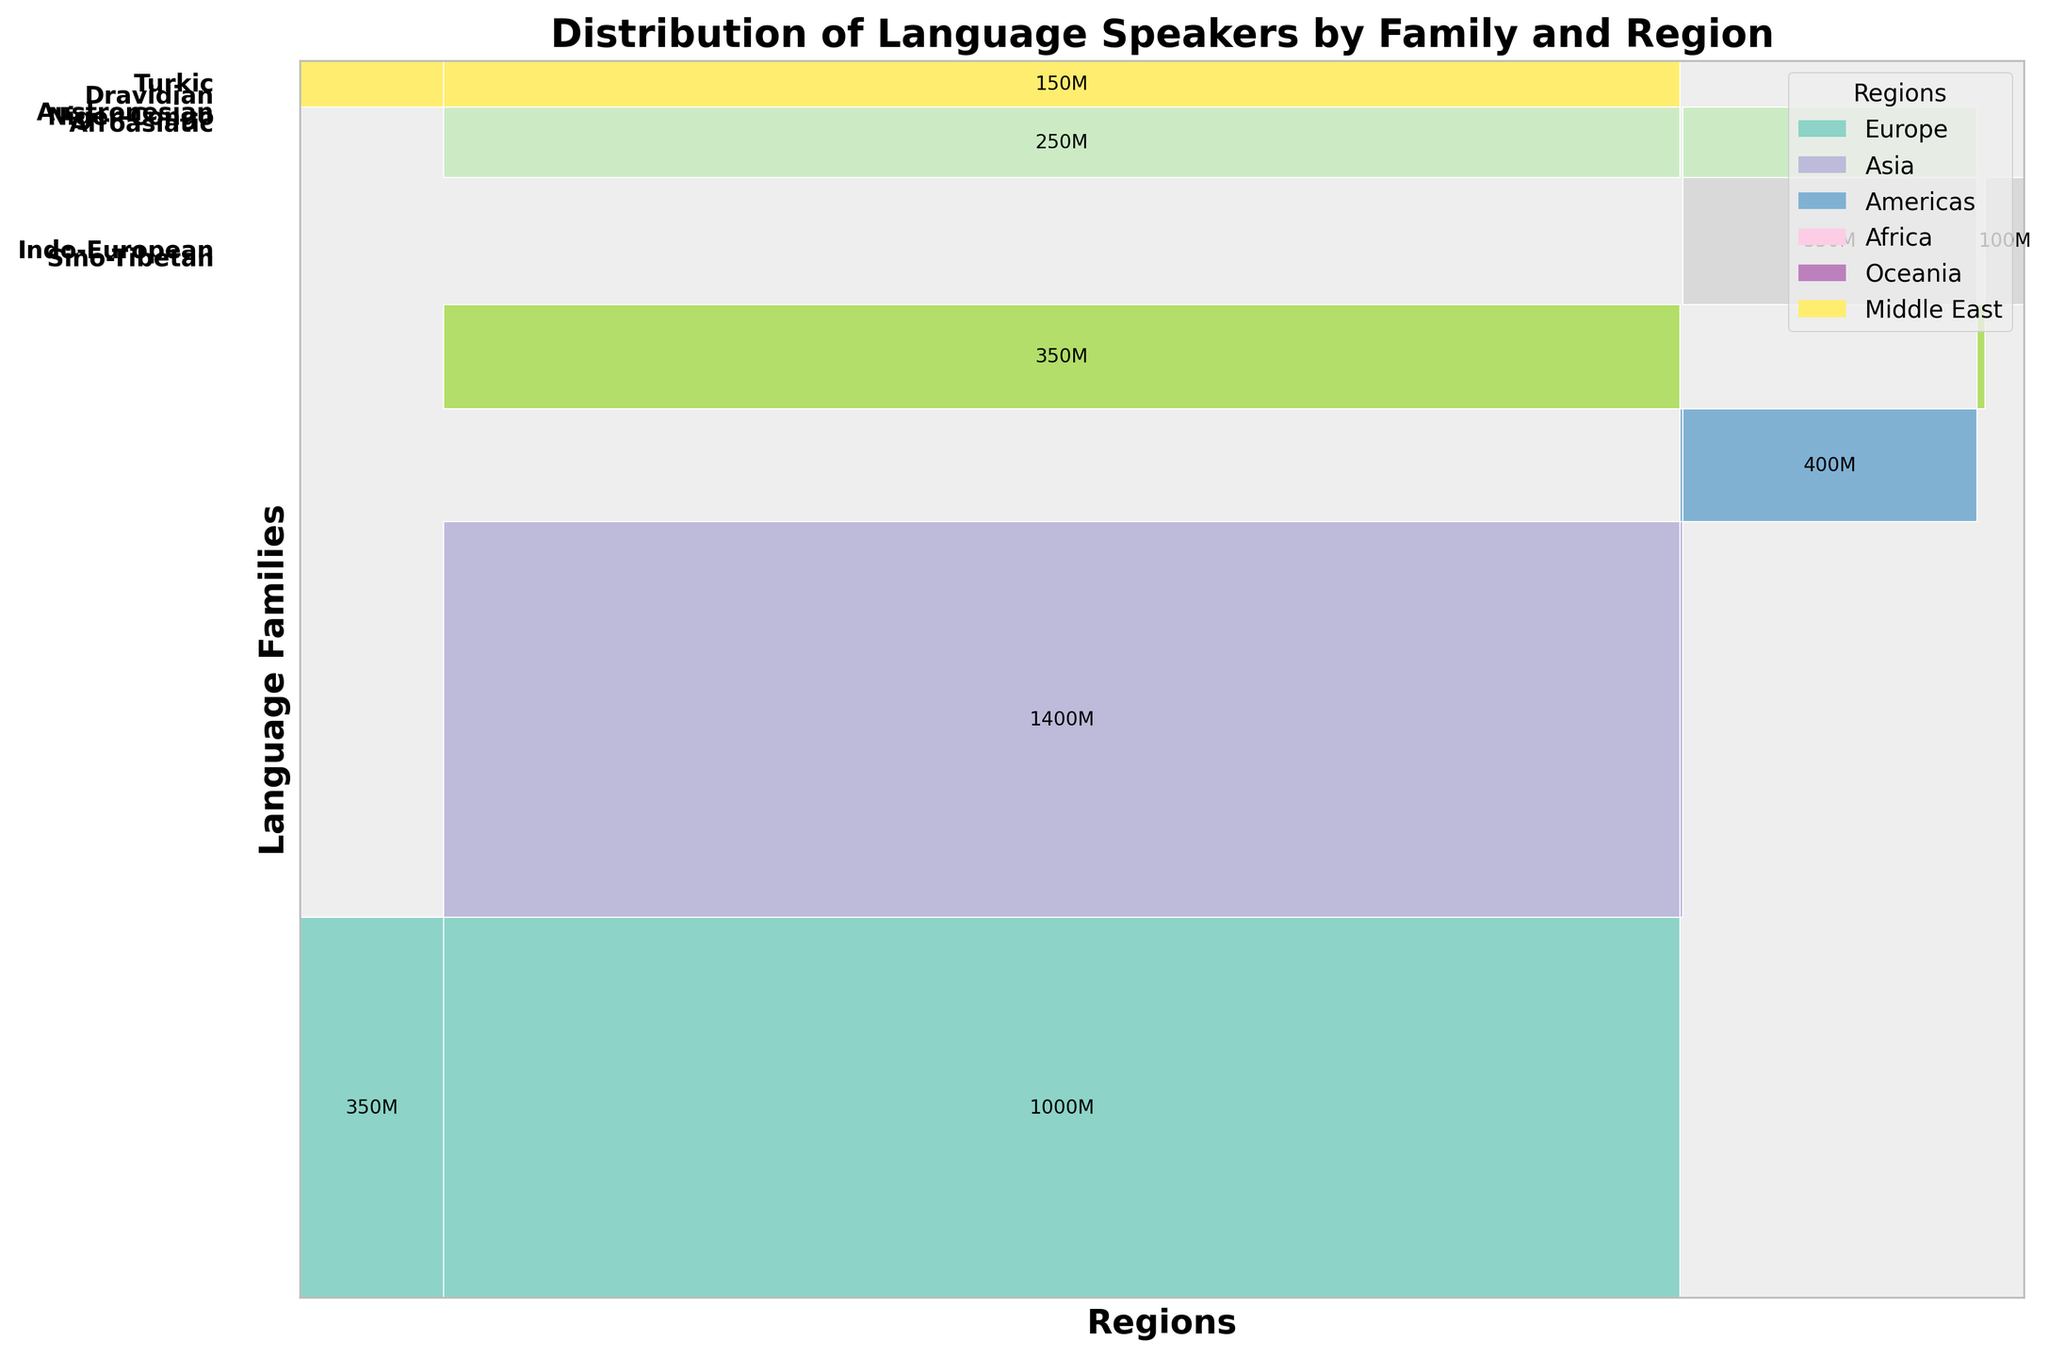What does the title of the mosaic plot indicate? The title usually gives a summary of what the plot represents. In this case, the title "Distribution of Language Speakers by Family and Region" indicates that the plot shows how speakers of different language families are distributed across various geographic regions.
Answer: Distribution of Language Speakers by Family and Region Which language family has the largest number of speakers in Asia? To answer this, look for the language family section with the largest block in the Asia region. In the mosaic plot, the Sino-Tibetan language family occupies the largest area in Asia.
Answer: Sino-Tibetan How many language families are shown in the figure? Each distinct color block in the vertical axis denotes a separate language family. By counting the labels on the vertical axis, we can determine the number of language families.
Answer: 7 What's the total number of language speakers for the Indo-European family across all regions? To find this, add the number of speakers in each region for the Indo-European language family. Referring to the plot, it’s 350 million in Europe and 1 billion in Asia.
Answer: 1.35 billion Which region has the fewest language speakers for Niger-Congo languages? For each region linked to the Niger-Congo family, compare the sizes of the corresponding regions. The Americas has the smallest area for the Niger-Congo language family on the plot.
Answer: Americas How many regions are represented in the mosaic plot? Each distinct color block on the horizontal axis denotes a separate region. By counting the labels on the horizontal axis, we can determine the number of regions.
Answer: 6 Is the Afroasiatic family more prevalent in Africa or the Middle East? Compare the corresponding areas (rectangles) for the Afroasiatic family in Africa and the Middle East. The Afroasiatic section in Africa is larger than in the Middle East.
Answer: Africa Which language family has the smallest block in the figure? Identify the smallest rectangle in the mosaic plot, which will indicate the language family with the smallest number of speakers across all regions. The Dravidian family in Africa is the smallest section.
Answer: Dravidian (Africa) Compare the number of speakers for the Austronesian family in Asia versus Oceania. Which region has more? Check the sizes of the Austronesian sections in both Asia and Oceania, then compare the numbers. Asia's section is larger, indicating more speakers.
Answer: Asia What's the second most spoken language family worldwide according to the plot? Look for the second largest block in the overall figure. The Indo-European family, especially due to its large sections in Asia and Europe, is the second-largest after Sino-Tibetan.
Answer: Indo-European 